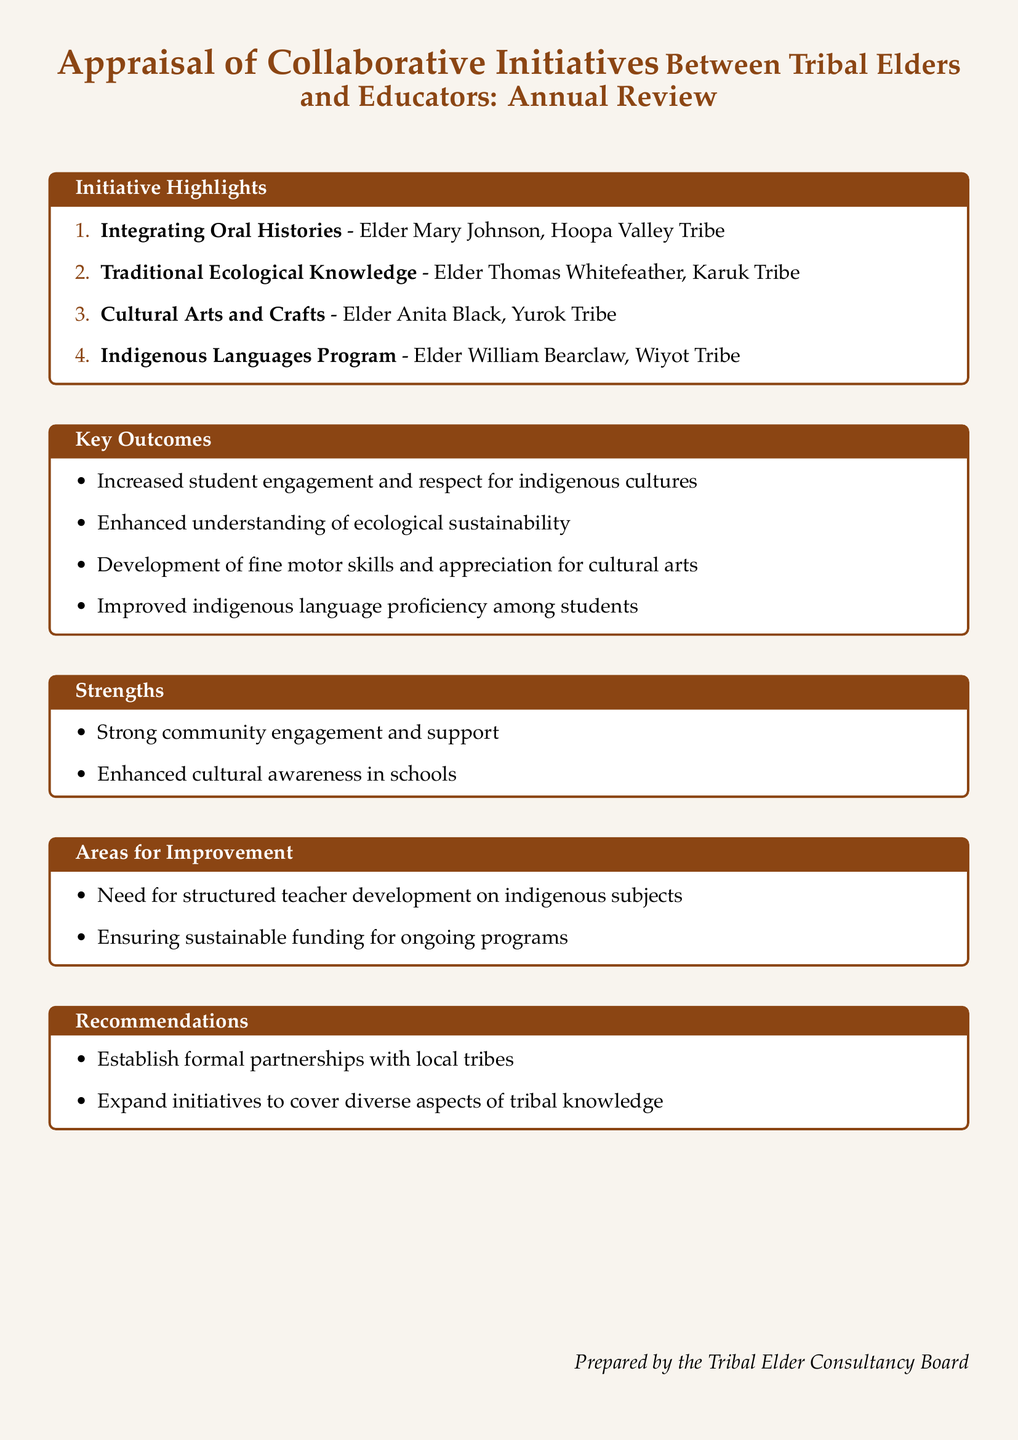What is the title of the document? The title of the document is located at the beginning and specifies the focus and nature of the appraisal.
Answer: Appraisal of Collaborative Initiatives Between Tribal Elders and Educators: Annual Review Who is the elder associated with the Indigenous Languages Program? The document lists the elders with their respective initiatives, and this information is found in the Initiative Highlights section.
Answer: Elder William Bearclaw What is one of the key outcomes related to cultural arts? This information can be found in the Key Outcomes section, which highlights the results of the collaborative initiatives.
Answer: Development of fine motor skills and appreciation for cultural arts What area is identified for improvement regarding teacher development? The Areas for Improvement section details specific needs for enhancement in the program, including teacher development topics.
Answer: Structured teacher development on indigenous subjects How many initiatives are highlighted in the document? The number of initiatives is indicated in the Initiative Highlights section, where each initiative is enumerated.
Answer: 4 